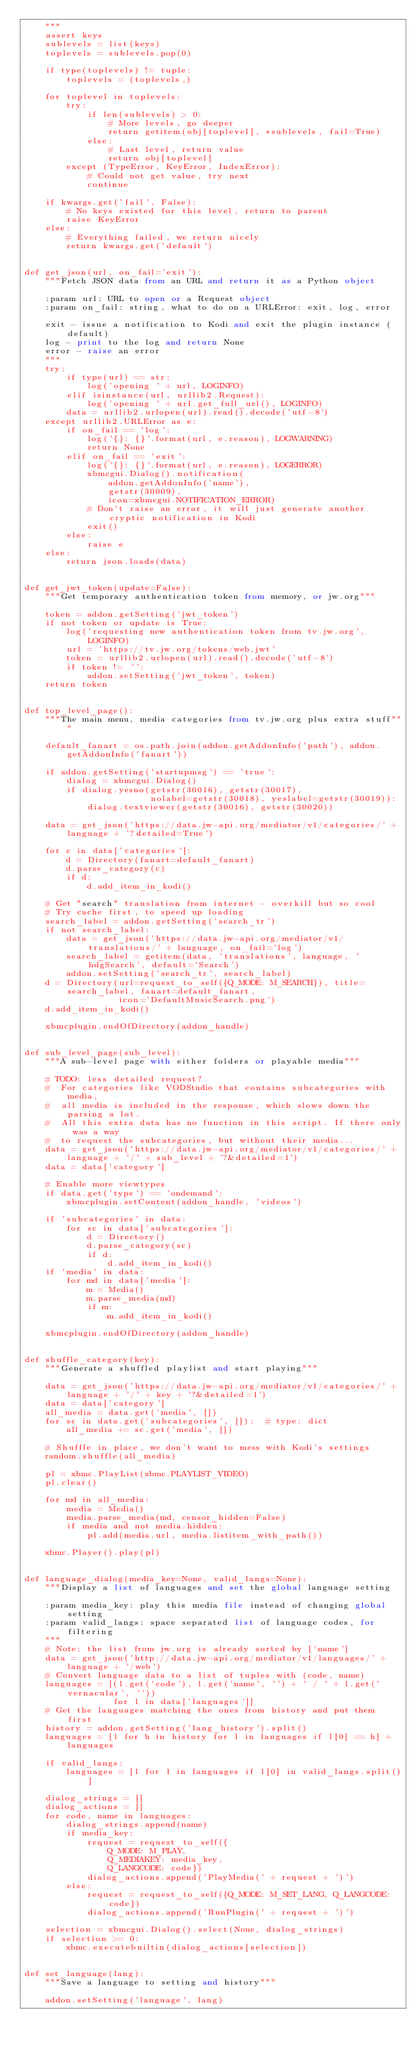Convert code to text. <code><loc_0><loc_0><loc_500><loc_500><_Python_>    """
    assert keys
    sublevels = list(keys)
    toplevels = sublevels.pop(0)

    if type(toplevels) != tuple:
        toplevels = (toplevels,)

    for toplevel in toplevels:
        try:
            if len(sublevels) > 0:
                # More levels, go deeper
                return getitem(obj[toplevel], *sublevels, fail=True)
            else:
                # Last level, return value
                return obj[toplevel]
        except (TypeError, KeyError, IndexError):
            # Could not get value, try next
            continue

    if kwargs.get('fail', False):
        # No keys existed for this level, return to parent
        raise KeyError
    else:
        # Everything failed, we return nicely
        return kwargs.get('default')


def get_json(url, on_fail='exit'):
    """Fetch JSON data from an URL and return it as a Python object

    :param url: URL to open or a Request object
    :param on_fail: string, what to do on a URLError: exit, log, error

    exit - issue a notification to Kodi and exit the plugin instance (default)
    log - print to the log and return None
    error - raise an error
    """
    try:
        if type(url) == str:
            log('opening ' + url, LOGINFO)
        elif isinstance(url, urllib2.Request):
            log('opening ' + url.get_full_url(), LOGINFO)
        data = urllib2.urlopen(url).read().decode('utf-8')
    except urllib2.URLError as e:
        if on_fail == 'log':
            log('{}: {}'.format(url, e.reason), LOGWARNING)
            return None
        elif on_fail == 'exit':
            log('{}: {}'.format(url, e.reason), LOGERROR)
            xbmcgui.Dialog().notification(
                addon.getAddonInfo('name'),
                getstr(30009),
                icon=xbmcgui.NOTIFICATION_ERROR)
            # Don't raise an error, it will just generate another cryptic notification in Kodi
            exit()
        else:
            raise e
    else:
        return json.loads(data)


def get_jwt_token(update=False):
    """Get temporary authentication token from memory, or jw.org"""

    token = addon.getSetting('jwt_token')
    if not token or update is True:
        log('requesting new authentication token from tv.jw.org', LOGINFO)
        url = 'https://tv.jw.org/tokens/web.jwt'
        token = urllib2.urlopen(url).read().decode('utf-8')
        if token != '':
            addon.setSetting('jwt_token', token)
    return token


def top_level_page():
    """The main menu, media categories from tv.jw.org plus extra stuff"""

    default_fanart = os.path.join(addon.getAddonInfo('path'), addon.getAddonInfo('fanart'))

    if addon.getSetting('startupmsg') == 'true':
        dialog = xbmcgui.Dialog()
        if dialog.yesno(getstr(30016), getstr(30017),
                        nolabel=getstr(30018), yeslabel=getstr(30019)):
            dialog.textviewer(getstr(30016), getstr(30020))

    data = get_json('https://data.jw-api.org/mediator/v1/categories/' + language + '?detailed=True')

    for c in data['categories']:
        d = Directory(fanart=default_fanart)
        d.parse_category(c)
        if d:
            d.add_item_in_kodi()

    # Get "search" translation from internet - overkill but so cool
    # Try cache first, to speed up loading
    search_label = addon.getSetting('search_tr')
    if not search_label:
        data = get_json('https://data.jw-api.org/mediator/v1/translations/' + language, on_fail='log')
        search_label = getitem(data, 'translations', language, 'hdgSearch', default='Search')
        addon.setSetting('search_tr', search_label)
    d = Directory(url=request_to_self({Q_MODE: M_SEARCH}), title=search_label, fanart=default_fanart,
                  icon='DefaultMusicSearch.png')
    d.add_item_in_kodi()

    xbmcplugin.endOfDirectory(addon_handle)


def sub_level_page(sub_level):
    """A sub-level page with either folders or playable media"""

    # TODO: less detailed request?
    #  For categories like VODStudio that contains subcategories with media,
    #  all media is included in the response, which slows down the parsing a lot.
    #  All this extra data has no function in this script. If there only was a way
    #  to request the subcategories, but without their media...
    data = get_json('https://data.jw-api.org/mediator/v1/categories/' + language + '/' + sub_level + '?&detailed=1')
    data = data['category']

    # Enable more viewtypes
    if data.get('type') == 'ondemand':
        xbmcplugin.setContent(addon_handle, 'videos')

    if 'subcategories' in data:
        for sc in data['subcategories']:
            d = Directory()
            d.parse_category(sc)
            if d:
                d.add_item_in_kodi()
    if 'media' in data:
        for md in data['media']:
            m = Media()
            m.parse_media(md)
            if m:
                m.add_item_in_kodi()

    xbmcplugin.endOfDirectory(addon_handle)


def shuffle_category(key):
    """Generate a shuffled playlist and start playing"""

    data = get_json('https://data.jw-api.org/mediator/v1/categories/' + language + '/' + key + '?&detailed=1')
    data = data['category']
    all_media = data.get('media', [])
    for sc in data.get('subcategories', []):  # type: dict
        all_media += sc.get('media', [])

    # Shuffle in place, we don't want to mess with Kodi's settings
    random.shuffle(all_media)

    pl = xbmc.PlayList(xbmc.PLAYLIST_VIDEO)
    pl.clear()

    for md in all_media:
        media = Media()
        media.parse_media(md, censor_hidden=False)
        if media and not media.hidden:
            pl.add(media.url, media.listitem_with_path())

    xbmc.Player().play(pl)


def language_dialog(media_key=None, valid_langs=None):
    """Display a list of languages and set the global language setting

    :param media_key: play this media file instead of changing global setting
    :param valid_langs: space separated list of language codes, for filtering
    """
    # Note: the list from jw.org is already sorted by ['name']
    data = get_json('http://data.jw-api.org/mediator/v1/languages/' + language + '/web')
    # Convert language data to a list of tuples with (code, name)
    languages = [(l.get('code'), l.get('name', '') + ' / ' + l.get('vernacular', ''))
                 for l in data['languages']]
    # Get the languages matching the ones from history and put them first
    history = addon.getSetting('lang_history').split()
    languages = [l for h in history for l in languages if l[0] == h] + languages

    if valid_langs:
        languages = [l for l in languages if l[0] in valid_langs.split()]

    dialog_strings = []
    dialog_actions = []
    for code, name in languages:
        dialog_strings.append(name)
        if media_key:
            request = request_to_self({
                Q_MODE: M_PLAY,
                Q_MEDIAKEY: media_key,
                Q_LANGCODE: code})
            dialog_actions.append('PlayMedia(' + request + ')')
        else:
            request = request_to_self({Q_MODE: M_SET_LANG, Q_LANGCODE: code})
            dialog_actions.append('RunPlugin(' + request + ')')

    selection = xbmcgui.Dialog().select(None, dialog_strings)
    if selection >= 0:
        xbmc.executebuiltin(dialog_actions[selection])


def set_language(lang):
    """Save a language to setting and history"""

    addon.setSetting('language', lang)</code> 